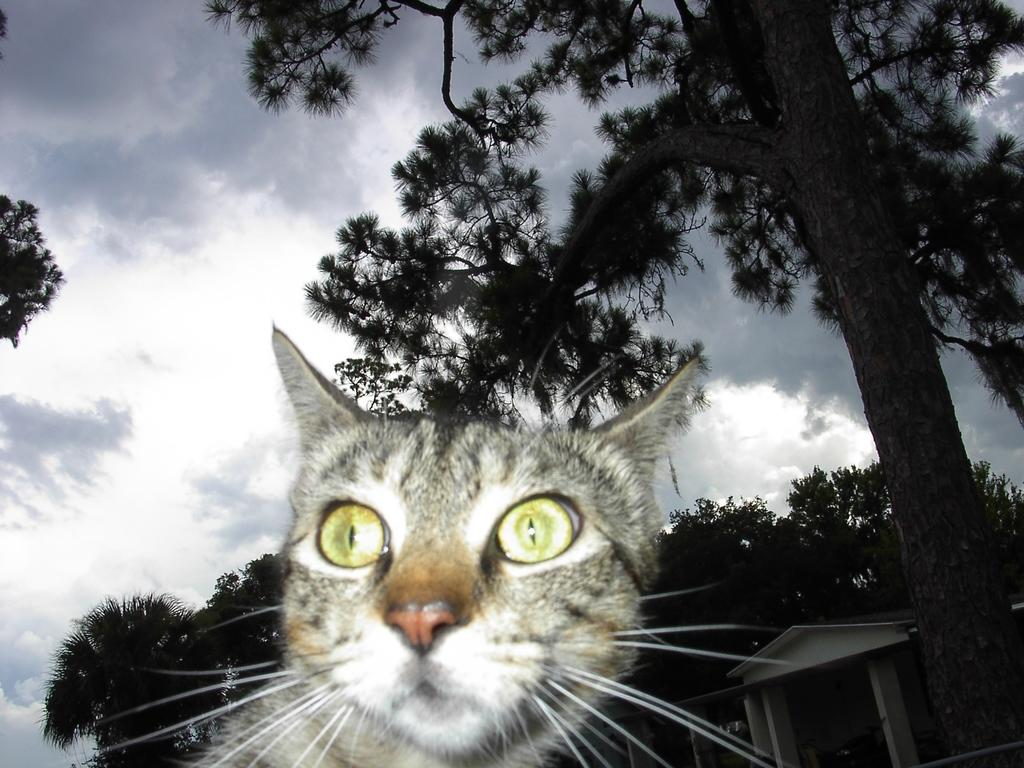What type of animal is in the image? There is a cat in the image. What can be seen in the background of the image? There are trees and a building in the background of the image. What is visible at the top of the image? The sky is visible at the top of the image. What type of soup is being served in the church in the image? There is no church or soup present in the image; it features a cat and background elements. 